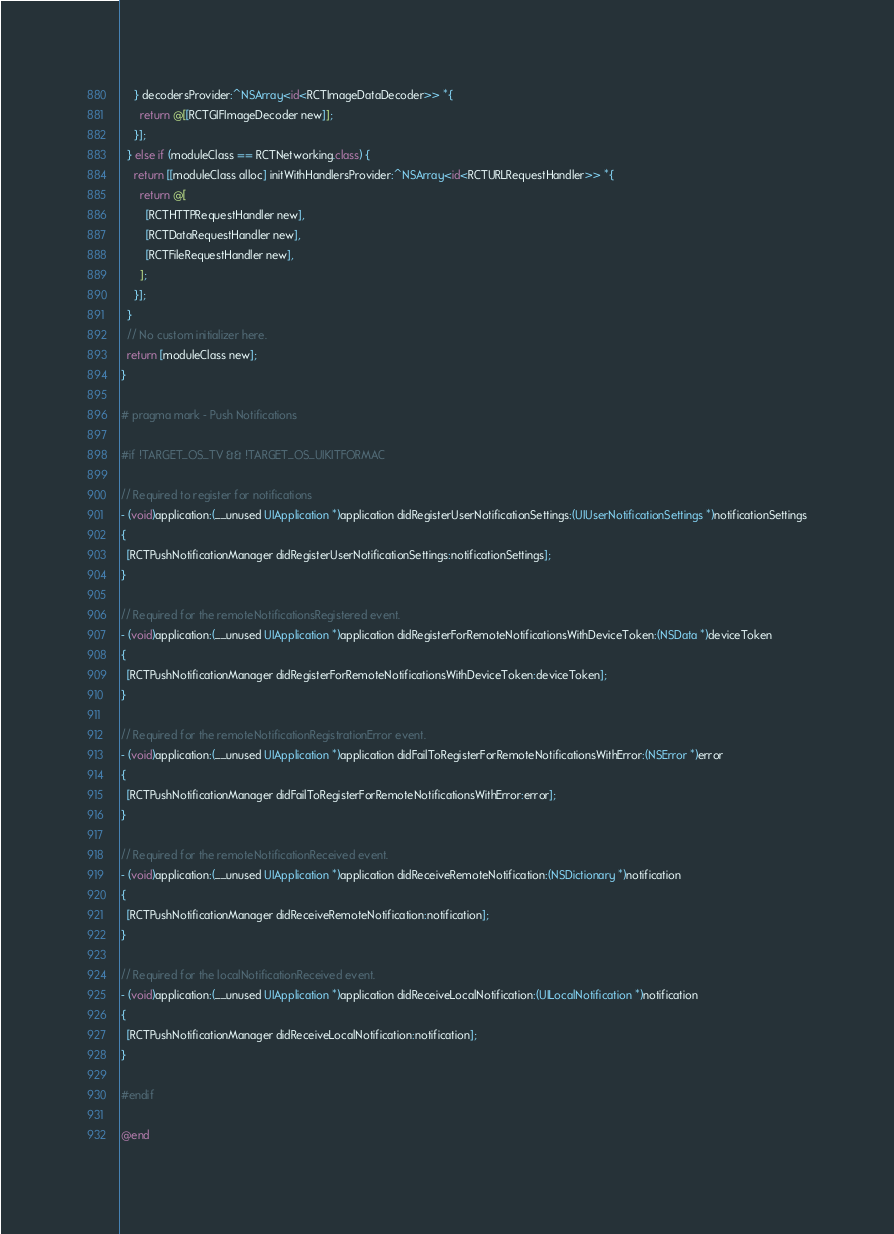<code> <loc_0><loc_0><loc_500><loc_500><_ObjectiveC_>    } decodersProvider:^NSArray<id<RCTImageDataDecoder>> *{
      return @[[RCTGIFImageDecoder new]];
    }];
  } else if (moduleClass == RCTNetworking.class) {
    return [[moduleClass alloc] initWithHandlersProvider:^NSArray<id<RCTURLRequestHandler>> *{
      return @[
        [RCTHTTPRequestHandler new],
        [RCTDataRequestHandler new],
        [RCTFileRequestHandler new],
      ];
    }];
  }
  // No custom initializer here.
  return [moduleClass new];
}

# pragma mark - Push Notifications

#if !TARGET_OS_TV && !TARGET_OS_UIKITFORMAC

// Required to register for notifications
- (void)application:(__unused UIApplication *)application didRegisterUserNotificationSettings:(UIUserNotificationSettings *)notificationSettings
{
  [RCTPushNotificationManager didRegisterUserNotificationSettings:notificationSettings];
}

// Required for the remoteNotificationsRegistered event.
- (void)application:(__unused UIApplication *)application didRegisterForRemoteNotificationsWithDeviceToken:(NSData *)deviceToken
{
  [RCTPushNotificationManager didRegisterForRemoteNotificationsWithDeviceToken:deviceToken];
}

// Required for the remoteNotificationRegistrationError event.
- (void)application:(__unused UIApplication *)application didFailToRegisterForRemoteNotificationsWithError:(NSError *)error
{
  [RCTPushNotificationManager didFailToRegisterForRemoteNotificationsWithError:error];
}

// Required for the remoteNotificationReceived event.
- (void)application:(__unused UIApplication *)application didReceiveRemoteNotification:(NSDictionary *)notification
{
  [RCTPushNotificationManager didReceiveRemoteNotification:notification];
}

// Required for the localNotificationReceived event.
- (void)application:(__unused UIApplication *)application didReceiveLocalNotification:(UILocalNotification *)notification
{
  [RCTPushNotificationManager didReceiveLocalNotification:notification];
}

#endif

@end
</code> 